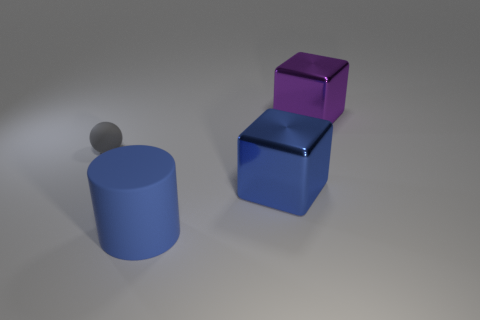Subtract all green cylinders. Subtract all gray balls. How many cylinders are left? 1 Add 4 tiny yellow cubes. How many objects exist? 8 Subtract all cylinders. How many objects are left? 3 Subtract all small gray rubber objects. Subtract all blue cylinders. How many objects are left? 2 Add 3 blue blocks. How many blue blocks are left? 4 Add 3 tiny purple matte things. How many tiny purple matte things exist? 3 Subtract 0 red balls. How many objects are left? 4 